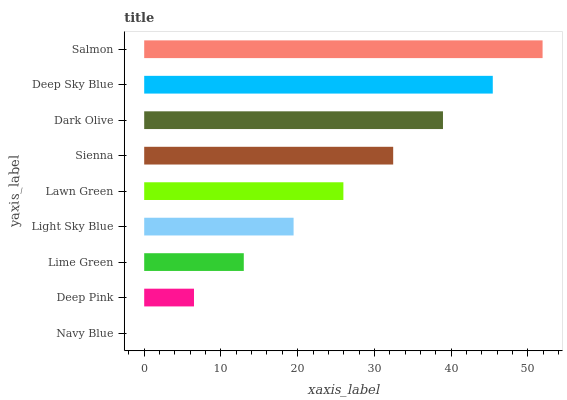Is Navy Blue the minimum?
Answer yes or no. Yes. Is Salmon the maximum?
Answer yes or no. Yes. Is Deep Pink the minimum?
Answer yes or no. No. Is Deep Pink the maximum?
Answer yes or no. No. Is Deep Pink greater than Navy Blue?
Answer yes or no. Yes. Is Navy Blue less than Deep Pink?
Answer yes or no. Yes. Is Navy Blue greater than Deep Pink?
Answer yes or no. No. Is Deep Pink less than Navy Blue?
Answer yes or no. No. Is Lawn Green the high median?
Answer yes or no. Yes. Is Lawn Green the low median?
Answer yes or no. Yes. Is Dark Olive the high median?
Answer yes or no. No. Is Deep Pink the low median?
Answer yes or no. No. 